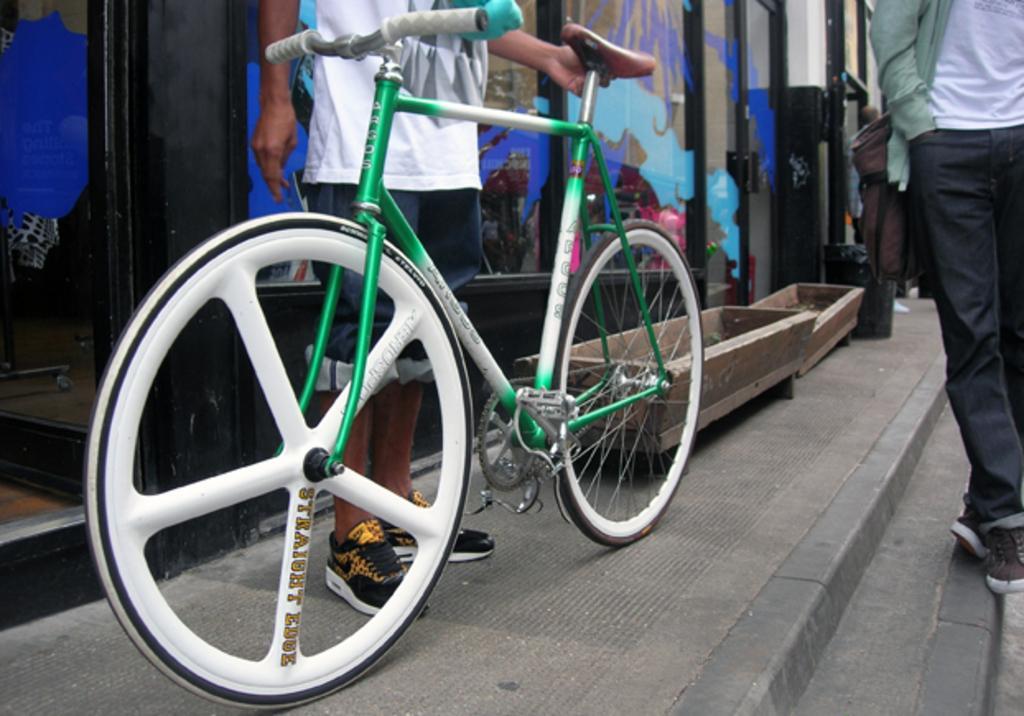Please provide a concise description of this image. In this picture I can see there is a bicycle and there are few people standing and there is a glass door in the backdrop. 